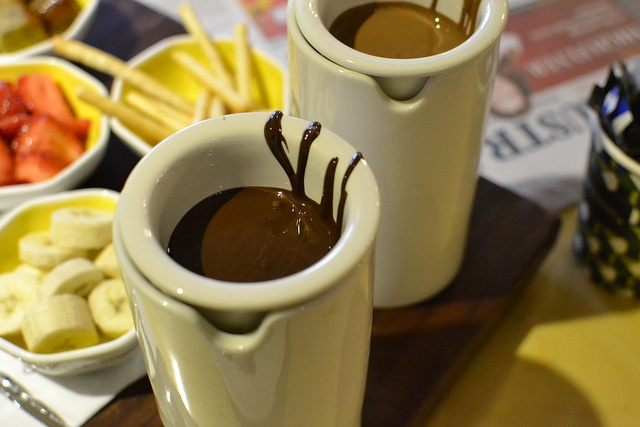Describe the objects in this image and their specific colors. I can see cup in olive, tan, and black tones, cup in olive and tan tones, bowl in olive, tan, black, and maroon tones, bowl in olive, khaki, and tan tones, and banana in olive, khaki, and tan tones in this image. 